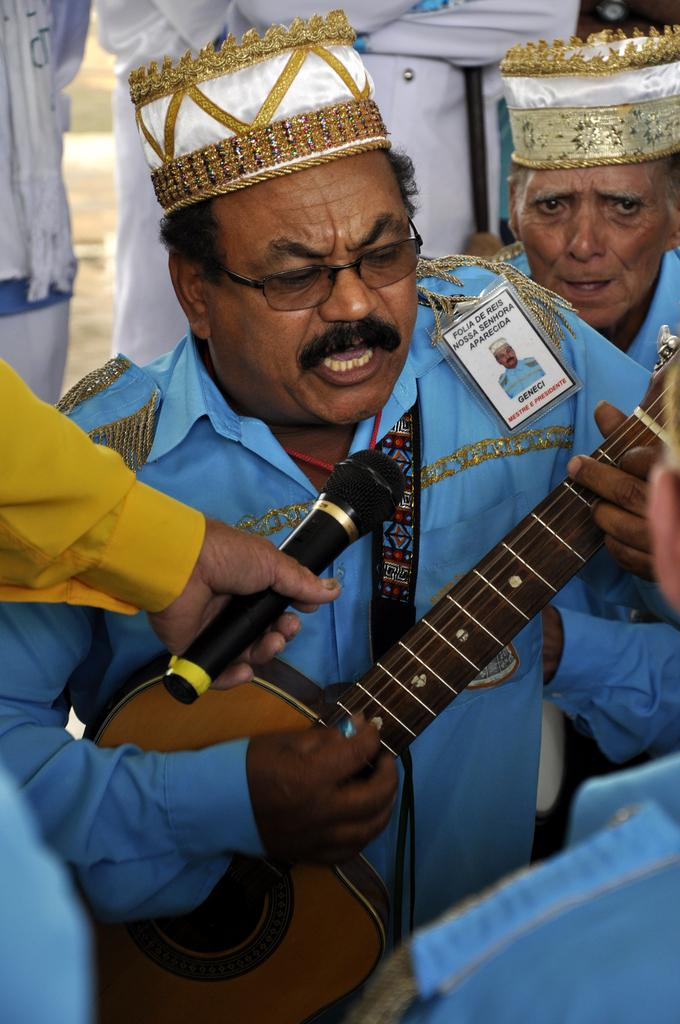What is the man in the image holding? The man in the image is holding a guitar. What is the man doing with the guitar? The man is speaking while holding the guitar. What can be seen on the left side of the image? There is a person's hand holding a microphone on the left side of the image. Can you describe the background of the image? There are people visible in the background of the image. How does the hammer help the man play the guitar in the image? There is no hammer present in the image, and it is not related to playing the guitar. 